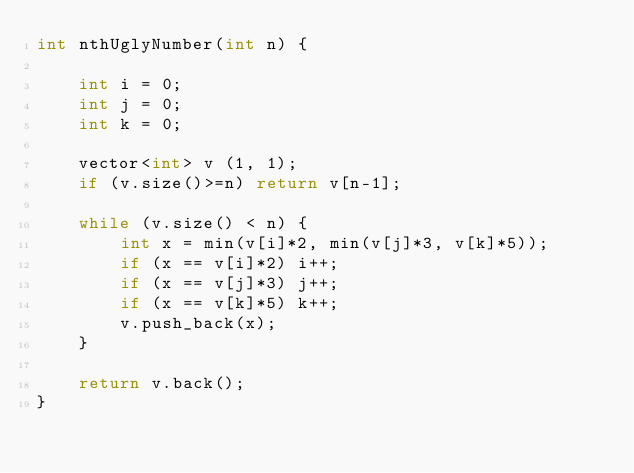<code> <loc_0><loc_0><loc_500><loc_500><_C++_>int nthUglyNumber(int n) {
    
    int i = 0;
    int j = 0;
    int k = 0;
    
    vector<int> v (1, 1);
    if (v.size()>=n) return v[n-1];
    
    while (v.size() < n) {
        int x = min(v[i]*2, min(v[j]*3, v[k]*5));
        if (x == v[i]*2) i++;
        if (x == v[j]*3) j++;
        if (x == v[k]*5) k++;
        v.push_back(x);
    }
    
    return v.back();
}

</code> 